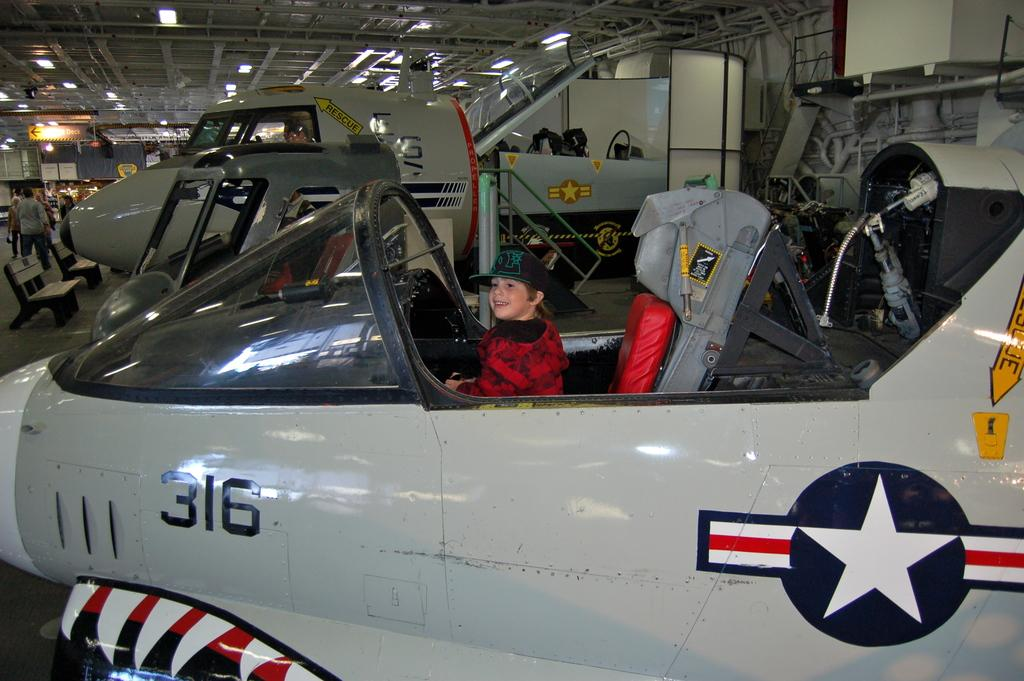<image>
Present a compact description of the photo's key features. The airplane is number 316 in the fleet. 